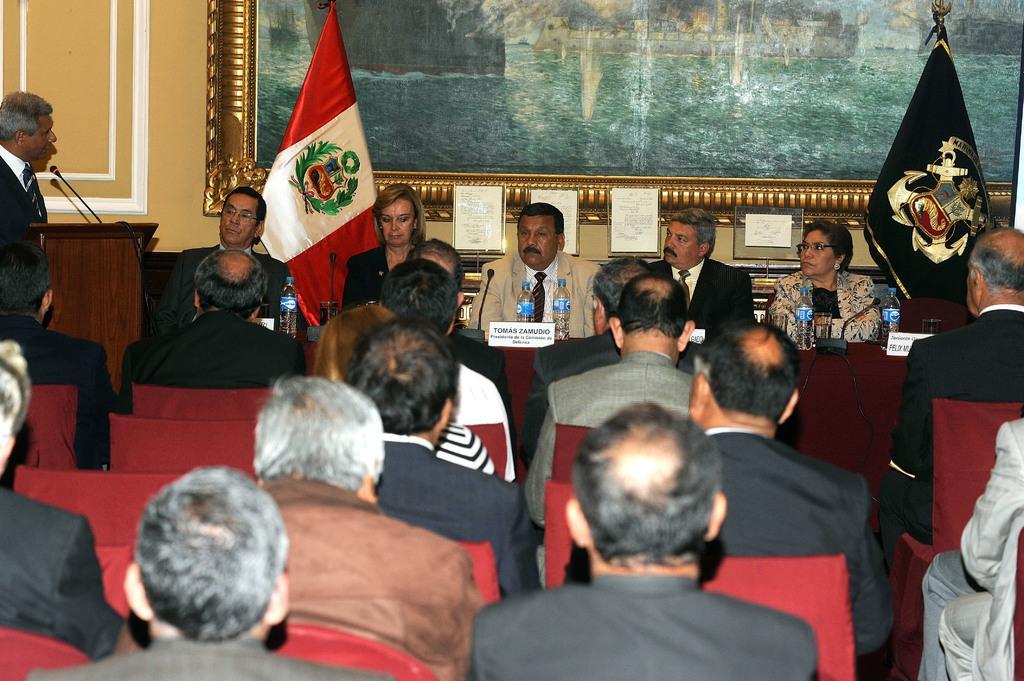In one or two sentences, can you explain what this image depicts? In the picture we can see some people are sitting on the chairs and in front of them, we can see five people are sitting near the desk and on the desk, we can see microphones, water bottles and name boards and behind them, we can see two flags and behind it we can see the poster with a painting and besides the people we can see a man standing near the desk and talking in the microphone. 